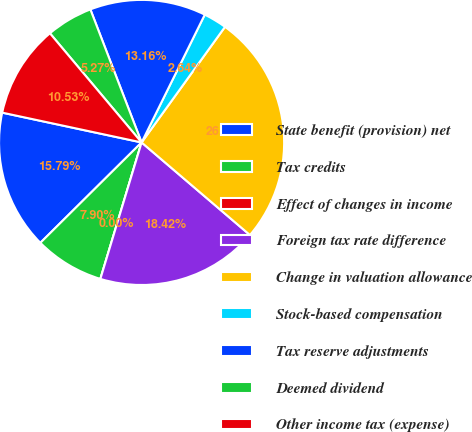<chart> <loc_0><loc_0><loc_500><loc_500><pie_chart><fcel>State benefit (provision) net<fcel>Tax credits<fcel>Effect of changes in income<fcel>Foreign tax rate difference<fcel>Change in valuation allowance<fcel>Stock-based compensation<fcel>Tax reserve adjustments<fcel>Deemed dividend<fcel>Other income tax (expense)<nl><fcel>15.79%<fcel>7.9%<fcel>0.0%<fcel>18.42%<fcel>26.31%<fcel>2.64%<fcel>13.16%<fcel>5.27%<fcel>10.53%<nl></chart> 